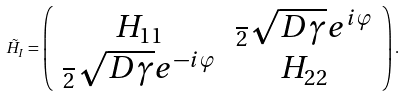<formula> <loc_0><loc_0><loc_500><loc_500>\tilde { H } _ { I } = \left ( \begin{array} { c c } H _ { 1 1 } & \frac { } { 2 } \sqrt { D \gamma } e ^ { i \varphi } \\ \frac { } { 2 } \sqrt { D \gamma } e ^ { - i \varphi } & H _ { 2 2 } \end{array} \right ) .</formula> 